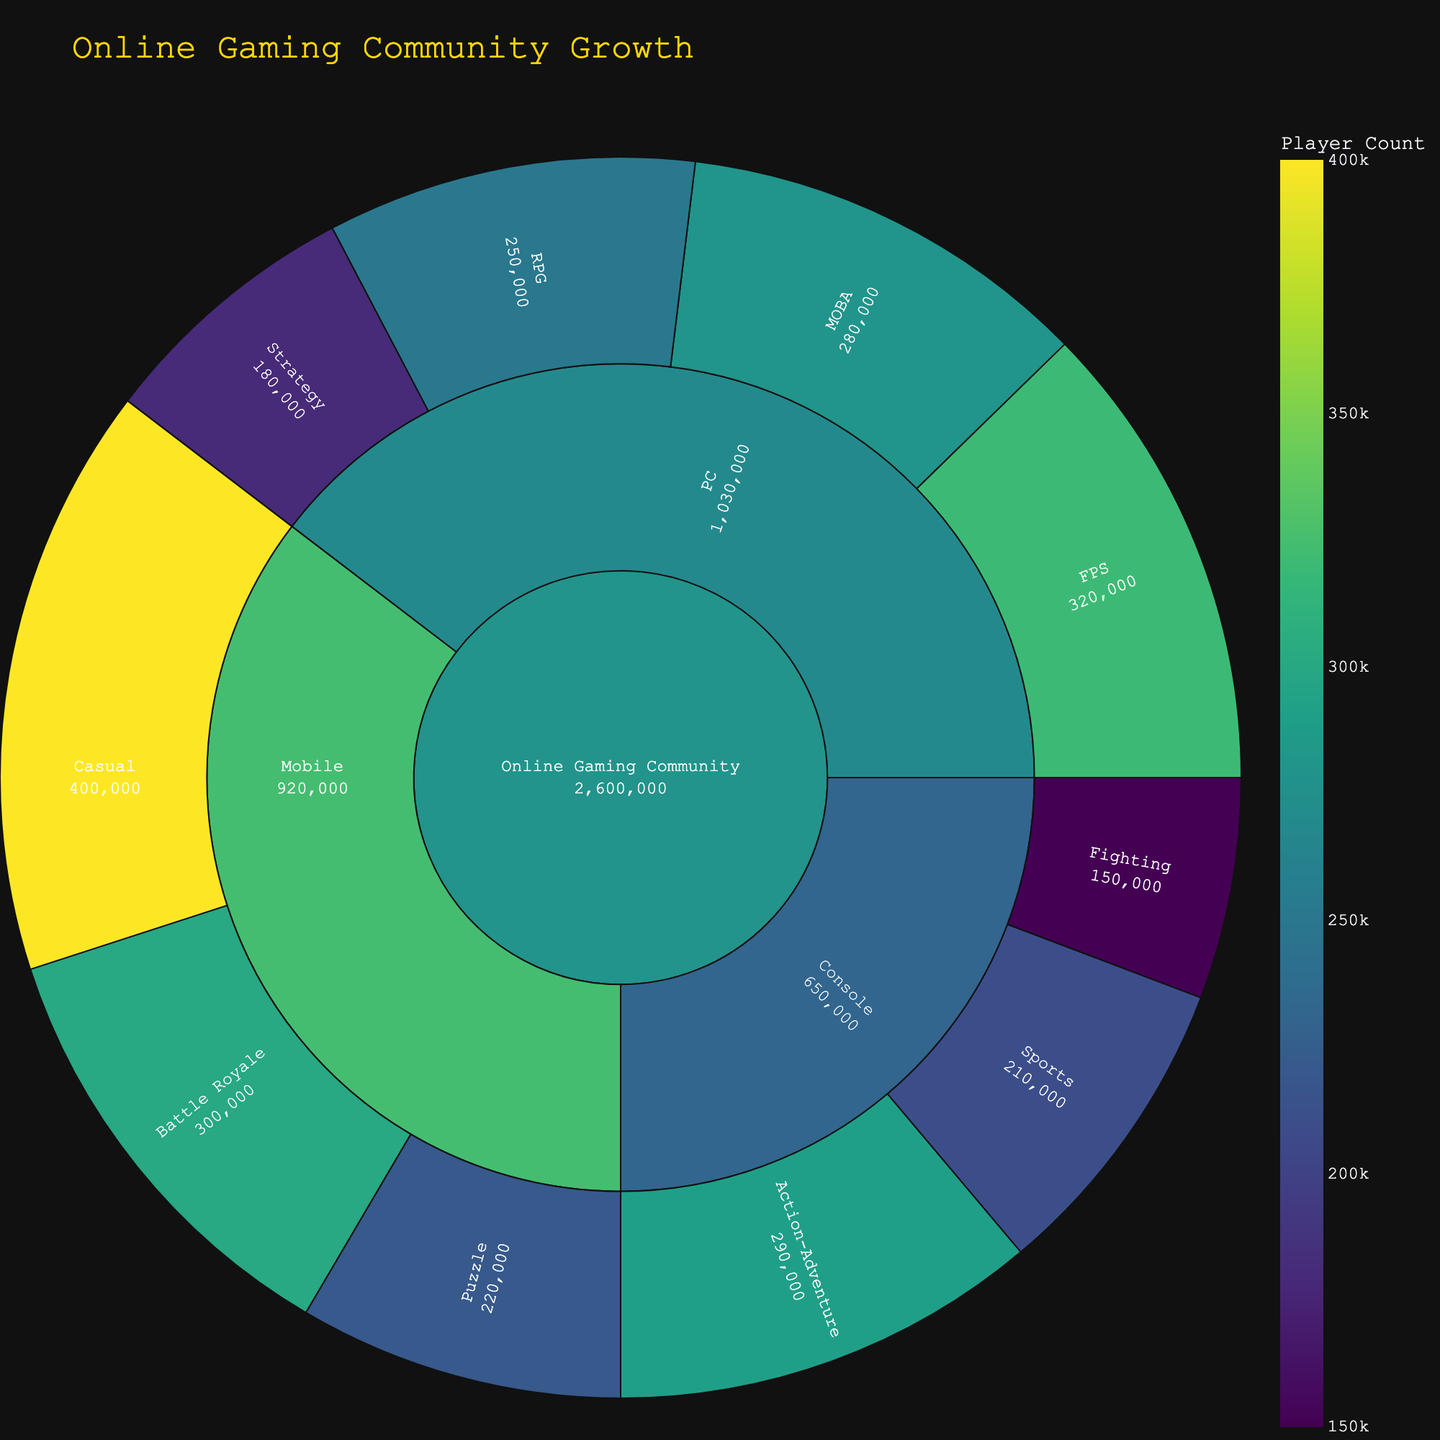What is the total number of players in the Online Gaming Community? To find the total number of players in the Online Gaming Community, sum the values across all game types and platforms: 250,000 (PC RPG) + 320,000 (PC FPS) + 280,000 (PC MOBA) + 180,000 (PC Strategy) + 290,000 (Console Action-Adventure) + 210,000 (Console Sports) + 150,000 (Console Fighting) + 400,000 (Mobile Casual) + 220,000 (Mobile Puzzle) + 300,000 (Mobile Battle Royale). The total is 2,600,000.
Answer: 2,600,000 Which game type on the PC platform has the highest number of players? On the PC platform, the game types and their player counts are: RPG (250,000), FPS (320,000), MOBA (280,000), and Strategy (180,000). The FPS game type has the highest number of players with 320,000 players.
Answer: FPS How many more players are in the Mobile Casual games compared to Mobile Puzzle games? The Mobile Casual games have 400,000 players and Mobile Puzzle games have 220,000 players. The difference is 400,000 - 220,000 = 180,000 more players in Mobile Casual games.
Answer: 180,000 What is the most popular game type on the Console platform? On the Console platform, the game types and their player counts are: Action-Adventure (290,000), Sports (210,000), and Fighting (150,000). The most popular game type is Action-Adventure with 290,000 players.
Answer: Action-Adventure Which platform has the least number of total players? Summing up the total players for each platform: PC (250,000 + 320,000 + 280,000 + 180,000 = 1,030,000), Console (290,000 + 210,000 + 150,000 = 650,000), and Mobile (400,000 + 220,000 + 300,000 = 920,000). The console platform has the least number of players with 650,000.
Answer: Console What percentage of the total Online Gaming Community is playing Mobile games? The total number of players in Mobile games is 920,000. The total number of players in the Online Gaming Community is 2,600,000. The percentage is (920,000 / 2,600,000) * 100 ≈ 35.38%.
Answer: 35.38% Compare the total number of players on the PC platform with the total number of players on the Mobile platform. The total number of players on the PC platform is 1,030,000 and the total number of players on the Mobile platform is 920,000. PC has more players than Mobile by 1,030,000 - 920,000 = 110,000 players.
Answer: 110,000 Among the three platforms (PC, Console, and Mobile), which one has the highest variety of game types? To determine the variety of game types, count the different game types under each platform: PC (4 types: RPG, FPS, MOBA, Strategy), Console (3 types: Action-Adventure, Sports, Fighting), and Mobile (3 types: Casual, Puzzle, Battle Royale). The PC platform has the highest variety with 4 game types.
Answer: PC What is the ratio of players in PC FPS games to Console Fighting games? The number of players in PC FPS games is 320,000 and in Console Fighting games is 150,000. The ratio is 320,000:150,000, which simplifies to 32:15.
Answer: 32:15 